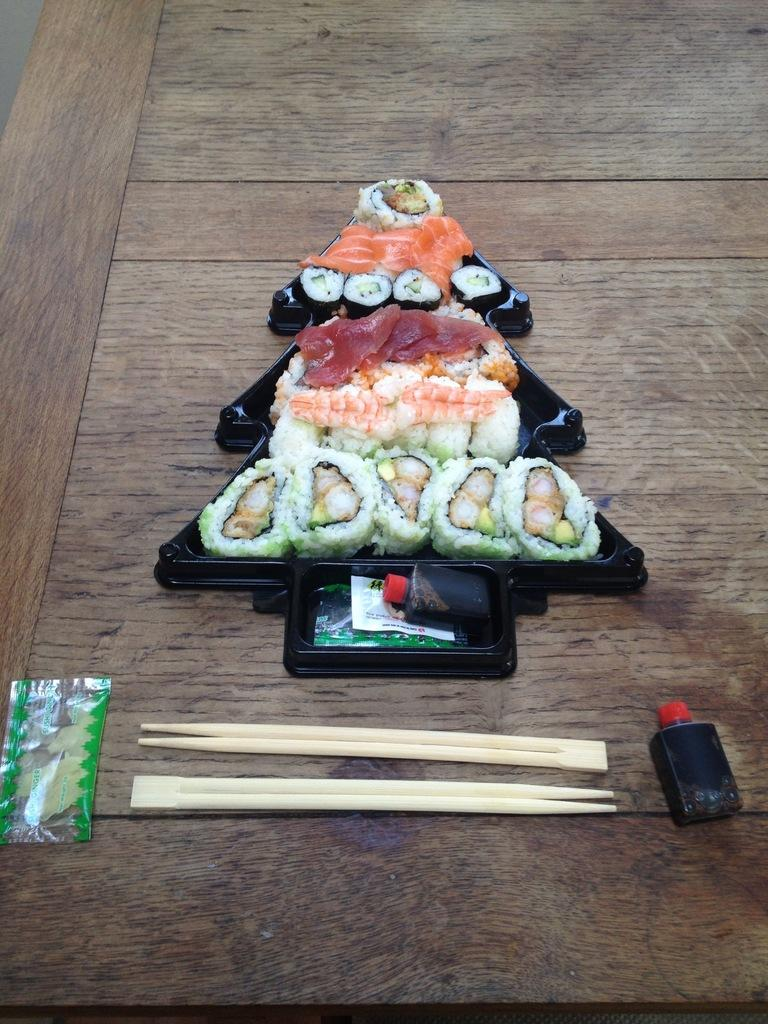What type of food can be seen in the image? There is a delicious food in the image. On what surface is the food placed? The food is on a wooden table. What objects are made of wood and visible in the image? There are wooden sticks in the image. What company is responsible for the sign in the image? There is no sign present in the image, so it is not possible to determine which company might be responsible. 